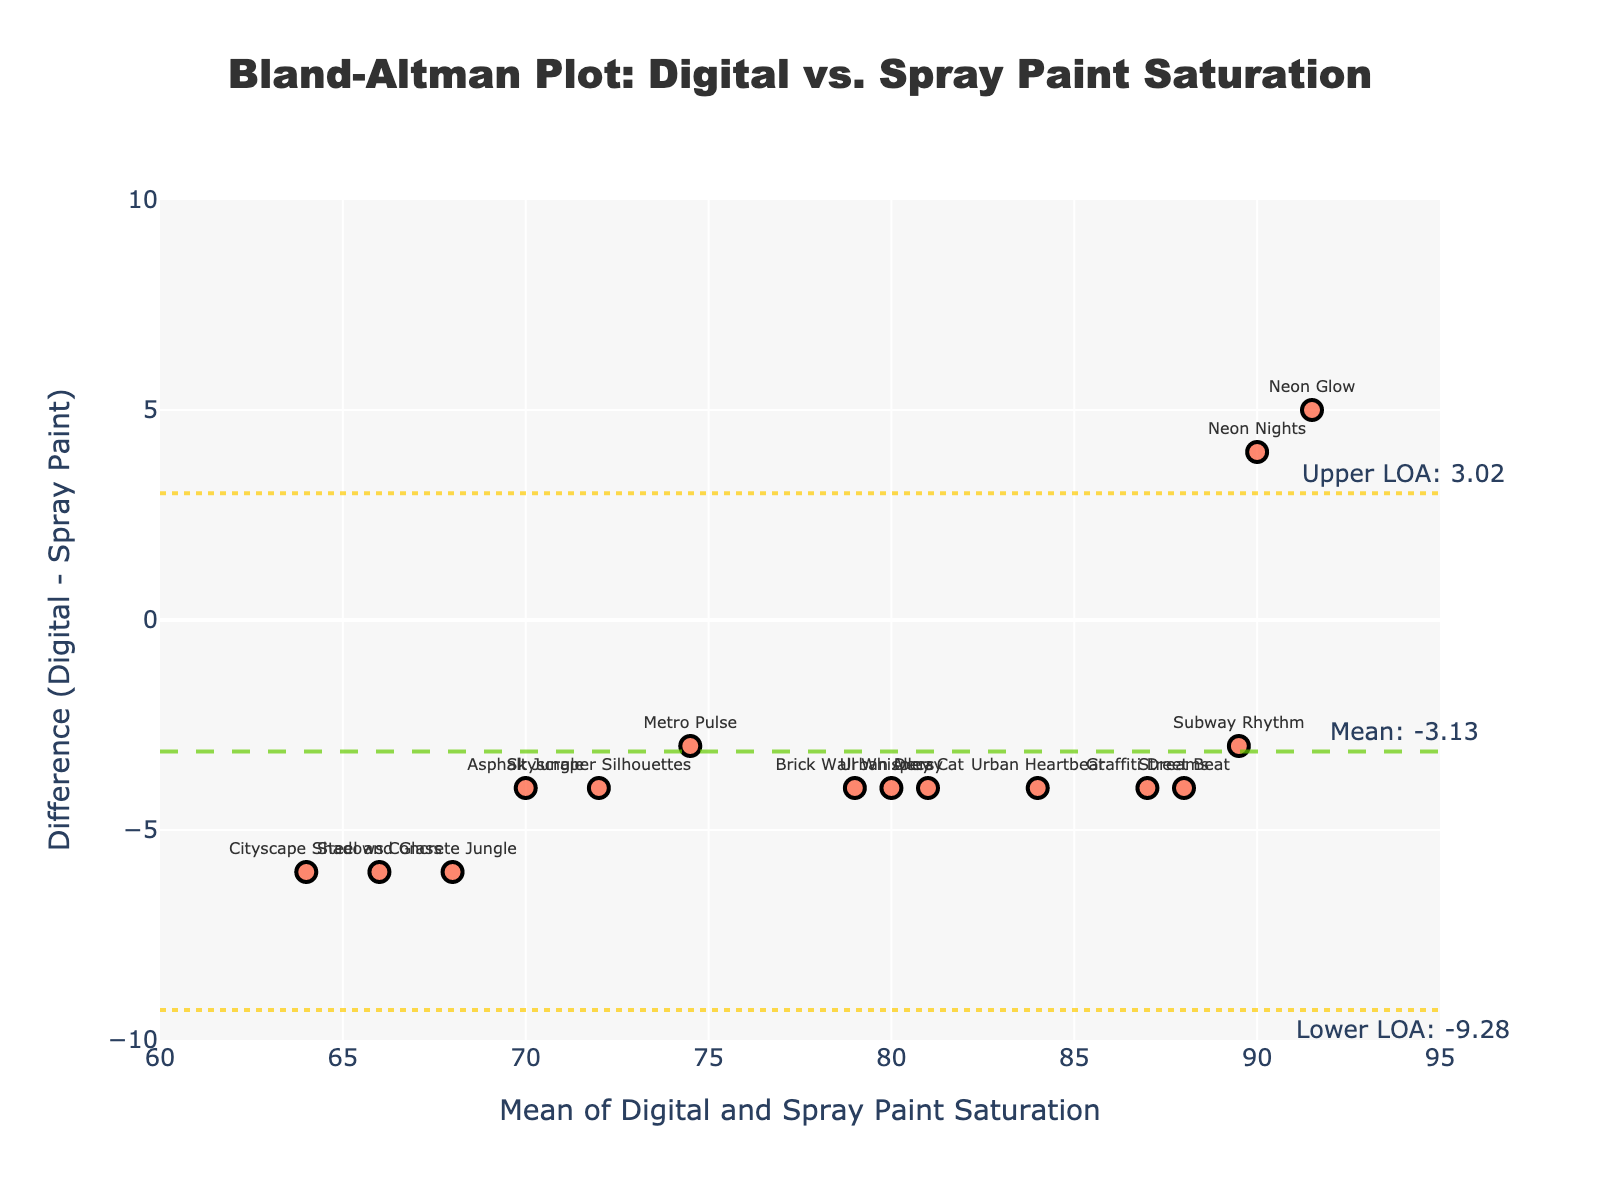What is the title of the plot? The title of the plot is located at the top-center of the figure. It describes the purpose of the plot.
Answer: Bland-Altman Plot: Digital vs. Spray Paint Saturation What does the x-axis represent? The x-axis title is located below the horizontal axis. It indicates the mean value of the saturation levels for both digital and spray paint artworks.
Answer: Mean of Digital and Spray Paint Saturation Which axis shows the difference between digital and spray paint saturation levels? The y-axis title is located next to the vertical axis, and it details the measurement shown on that axis.
Answer: Difference (Digital - Spray Paint) What is the mean difference between digital and spray paint saturation levels? The mean difference is shown by a dashed horizontal line and an annotation on the graph.
Answer: 0.53 What are the Upper and Lower Limits of Agreement (LOA)? The Upper and Lower LOAs are represented by dotted horizontal lines and are annotated to the right of the plot.
Answer: Upper LOA: 4.69, Lower LOA: -3.63 Which artwork shows the biggest difference in saturation levels, and what is this difference? By comparing the distance of points from the y=0 line, we can see which point is farthest. The artwork corresponding to the farthest point has the biggest difference.
Answer: Neon Glow, -5 Is there an artwork where the digital and spray paint saturation levels are equal? We check for a point where the y-coordinate (difference) is zero. There are no such points in the plot.
Answer: No Which artworks have a digital saturation level higher than the spray paint saturation level, and which artwork has the highest digital saturation? Look for points above the y=0 line for higher digital levels. We then identify the artwork with the highest mean on the x-axis.
Answer: Neon Nights, Graffiti Dreams, Subway Rhythm, Skyscraper Silhouettes, Alley Cat; Neon Glow How many artworks fall within the Limits of Agreement? Count all data points (artworks) that lie between the upper and lower LOA lines.
Answer: All 15 What is the average mean saturation value of all artworks? Calculate the mean of the x-axis values of all the data points by summing the means and dividing by the number of artworks: (78 + 90 + 68 + 87 + 74.5 + 89.5 + 64 + 81 + 72 + 88 + 70 + 79 + 91.5 + 66 + 84) / 15.
Answer: 78.87 